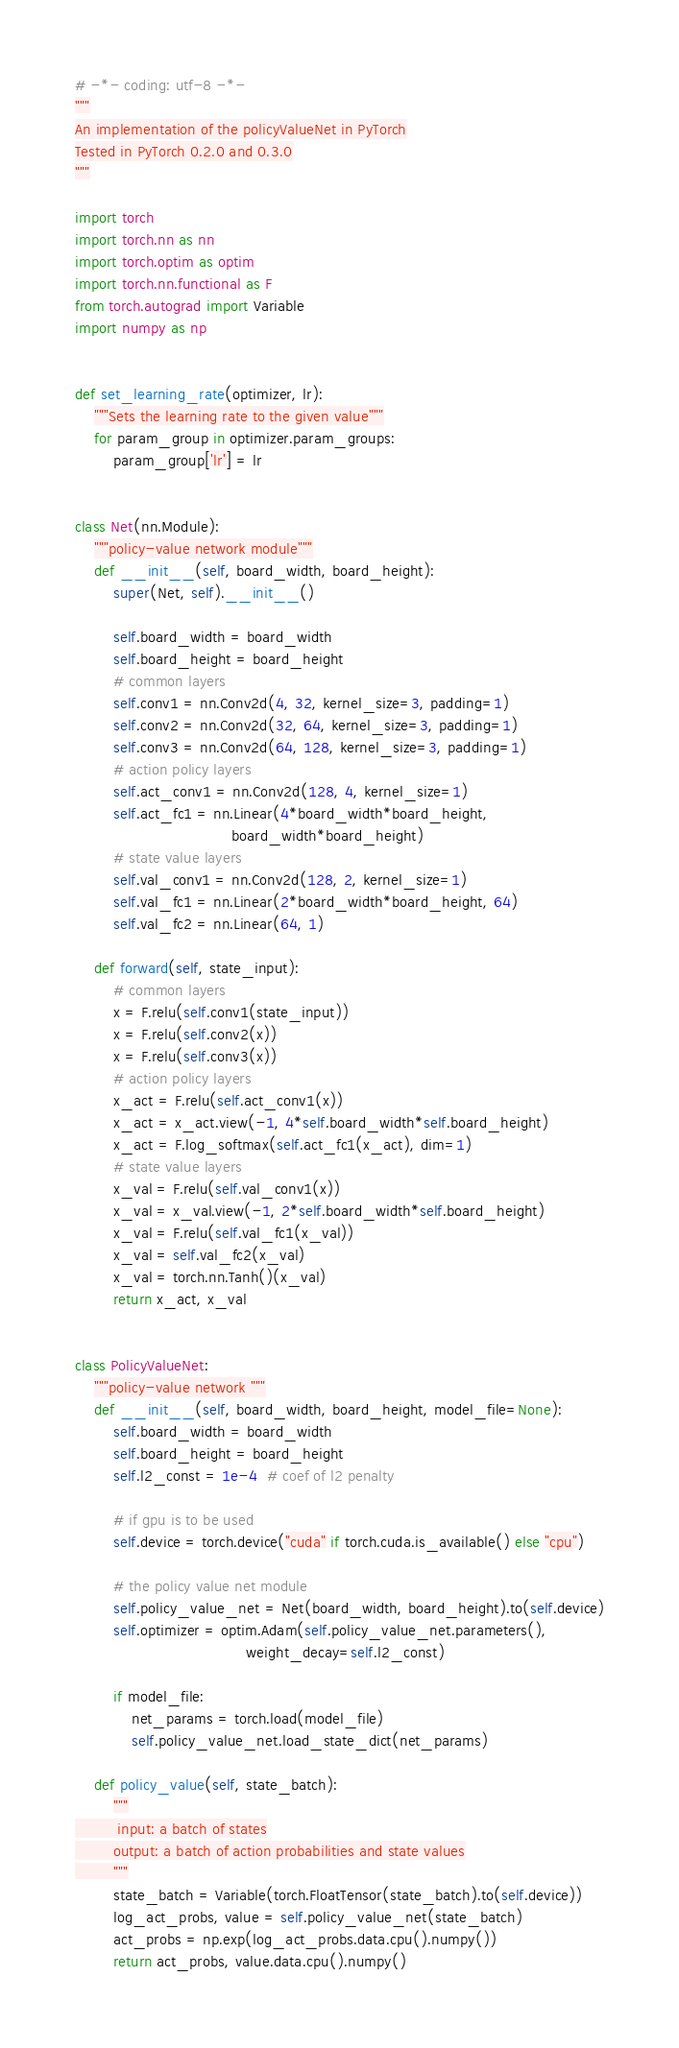<code> <loc_0><loc_0><loc_500><loc_500><_Python_># -*- coding: utf-8 -*-
"""
An implementation of the policyValueNet in PyTorch
Tested in PyTorch 0.2.0 and 0.3.0
"""

import torch
import torch.nn as nn
import torch.optim as optim
import torch.nn.functional as F
from torch.autograd import Variable
import numpy as np


def set_learning_rate(optimizer, lr):
    """Sets the learning rate to the given value"""
    for param_group in optimizer.param_groups:
        param_group['lr'] = lr


class Net(nn.Module):
    """policy-value network module"""
    def __init__(self, board_width, board_height):
        super(Net, self).__init__()

        self.board_width = board_width
        self.board_height = board_height
        # common layers
        self.conv1 = nn.Conv2d(4, 32, kernel_size=3, padding=1)
        self.conv2 = nn.Conv2d(32, 64, kernel_size=3, padding=1)
        self.conv3 = nn.Conv2d(64, 128, kernel_size=3, padding=1)
        # action policy layers
        self.act_conv1 = nn.Conv2d(128, 4, kernel_size=1)
        self.act_fc1 = nn.Linear(4*board_width*board_height,
                                 board_width*board_height)
        # state value layers
        self.val_conv1 = nn.Conv2d(128, 2, kernel_size=1)
        self.val_fc1 = nn.Linear(2*board_width*board_height, 64)
        self.val_fc2 = nn.Linear(64, 1)

    def forward(self, state_input):
        # common layers
        x = F.relu(self.conv1(state_input))
        x = F.relu(self.conv2(x))
        x = F.relu(self.conv3(x))
        # action policy layers
        x_act = F.relu(self.act_conv1(x))
        x_act = x_act.view(-1, 4*self.board_width*self.board_height)
        x_act = F.log_softmax(self.act_fc1(x_act), dim=1)
        # state value layers
        x_val = F.relu(self.val_conv1(x))
        x_val = x_val.view(-1, 2*self.board_width*self.board_height)
        x_val = F.relu(self.val_fc1(x_val))
        x_val = self.val_fc2(x_val)
        x_val = torch.nn.Tanh()(x_val)
        return x_act, x_val


class PolicyValueNet:
    """policy-value network """
    def __init__(self, board_width, board_height, model_file=None):
        self.board_width = board_width
        self.board_height = board_height
        self.l2_const = 1e-4  # coef of l2 penalty

        # if gpu is to be used
        self.device = torch.device("cuda" if torch.cuda.is_available() else "cpu")

        # the policy value net module
        self.policy_value_net = Net(board_width, board_height).to(self.device)
        self.optimizer = optim.Adam(self.policy_value_net.parameters(),
                                    weight_decay=self.l2_const)

        if model_file:
            net_params = torch.load(model_file)
            self.policy_value_net.load_state_dict(net_params)

    def policy_value(self, state_batch):
        """
         input: a batch of states
        output: a batch of action probabilities and state values
        """
        state_batch = Variable(torch.FloatTensor(state_batch).to(self.device))
        log_act_probs, value = self.policy_value_net(state_batch)
        act_probs = np.exp(log_act_probs.data.cpu().numpy())
        return act_probs, value.data.cpu().numpy()
</code> 